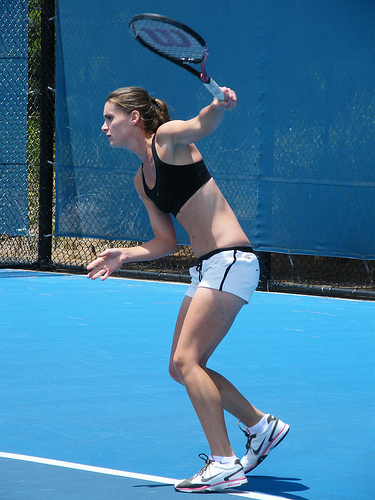Where in the picture is the tennis racket, in the bottom or in the top? The tennis racket is positioned towards the top of the image, as the person is holding it up high in preparation for a stroke. 